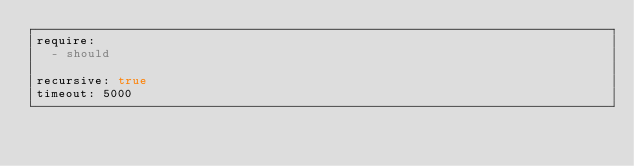<code> <loc_0><loc_0><loc_500><loc_500><_YAML_>require:
  - should

recursive: true
timeout: 5000
</code> 